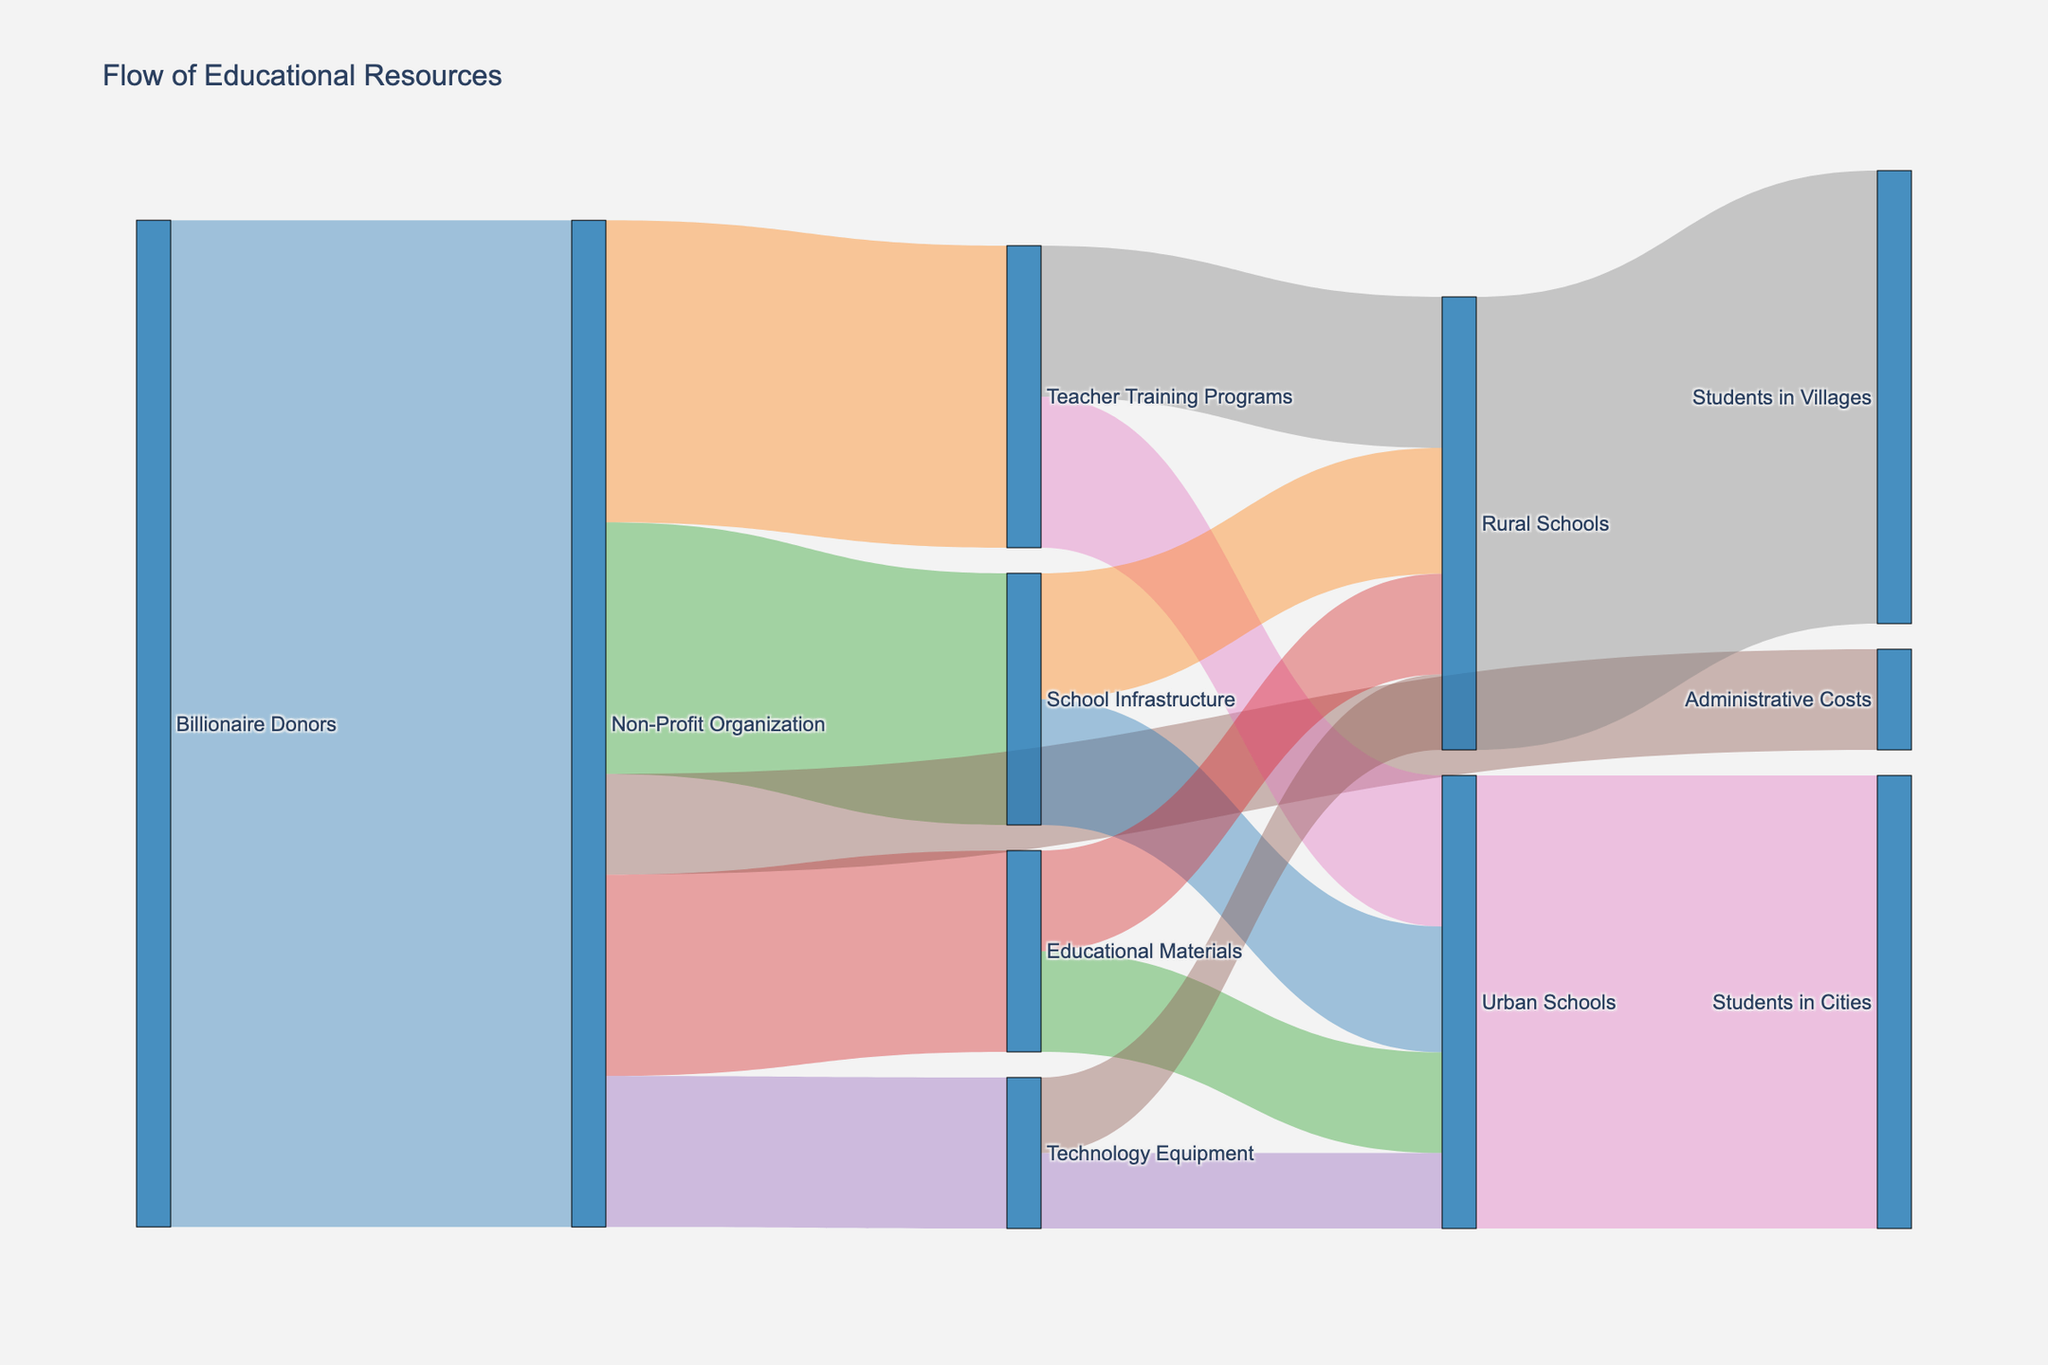What's the title of the figure? The title of the figure is prominently displayed at the top. It reads "Flow of Educational Resources"
Answer: Flow of Educational Resources How many donors are there in the chart? By looking at the source of the initial flow, we can see that there is only one donor labeled "Billionaire Donors" in the diagram
Answer: 1 Which category receives the largest amount of resources from the Non-Profit Organization? The size of the flows from the Non-Profit Organization to each category indicates the amount of resources. The largest flow is towards the Teacher Training Programs, which receives 3,000,000
Answer: Teacher Training Programs What are the total resources allocated to Urban Schools? To find the total resources, we sum the values flowing into Urban Schools: Teacher Training Programs (1,500,000), School Infrastructure (1,250,000), Educational Materials (1,000,000), and Technology Equipment (750,000). This totals 4,500,000
Answer: 4,500,000 Do Urban Schools and Rural Schools receive the same amount of resources from Non-Profit Organization? Comparing the sums of resources directed to Urban Schools and Rural Schools, both receive resources from Teacher Training Programs (1,500,000), School Infrastructure (1,250,000), Educational Materials (1,000,000), and Technology Equipment (750,000), totaling 4,500,000 each
Answer: Yes Which category receives the least amount of resources from the Non-Profit Organization? By comparing the sizes of the flows, Administrative Costs receives the least amount of resources at 1,000,000
Answer: Administrative Costs How much resources do Rural Schools receive for Teacher Training Programs? Follow the flow from the Non-Profit Organization to Teacher Training Programs and then to Rural Schools, which is listed as 1,500,000
Answer: 1,500,000 What is the total value of resources that flow through the Educational Materials category? Sum the values coming into Educational Materials (2,000,000) and the total distribution from it to Urban Schools (1,000,000) and Rural Schools (1,000,000), confirming that 2,000,000 is fully distributed
Answer: 2,000,000 How does the resource allocation to Urban Schools compare with that to Students in Cities? Resources allocated to Urban Schools flow into Students in Cities. Since all flows are directed towards the final beneficiaries as 4,500,000 for Students in Cities and the same for Urban Schools, they are equal
Answer: Equal 